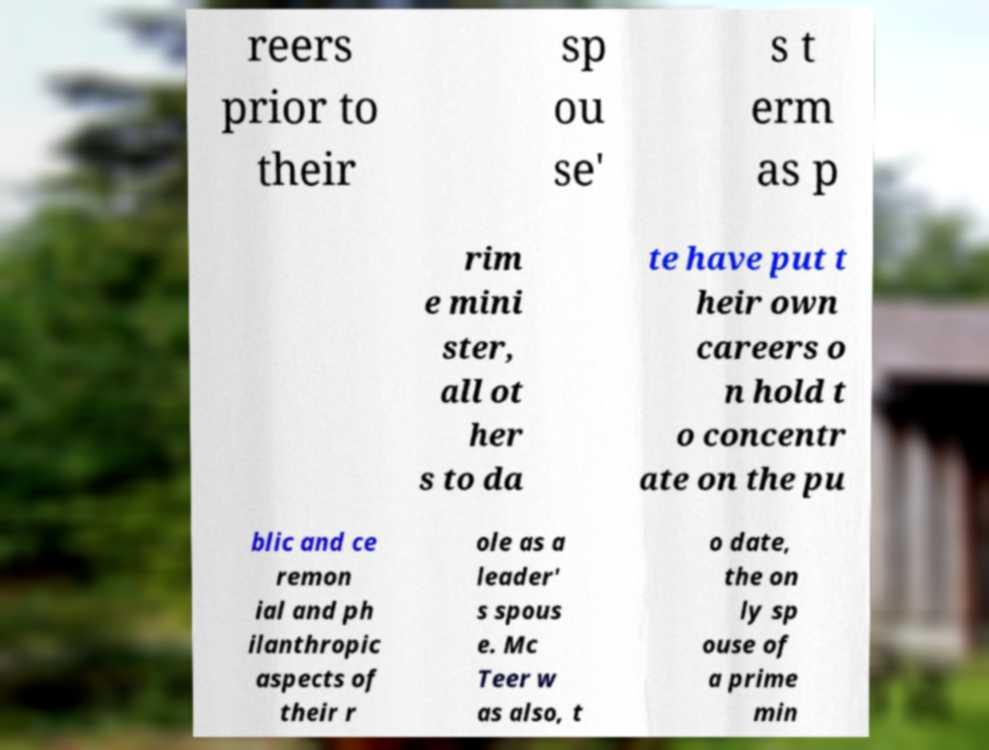Please identify and transcribe the text found in this image. reers prior to their sp ou se' s t erm as p rim e mini ster, all ot her s to da te have put t heir own careers o n hold t o concentr ate on the pu blic and ce remon ial and ph ilanthropic aspects of their r ole as a leader' s spous e. Mc Teer w as also, t o date, the on ly sp ouse of a prime min 